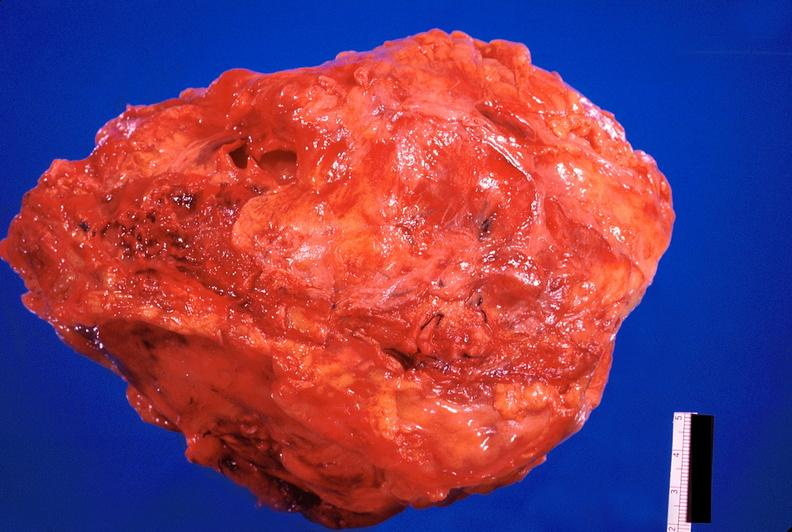does atrophy show pericarditis, secondary to mediastanitis from pseudomonas and enterobacter 14 days post op?
Answer the question using a single word or phrase. No 